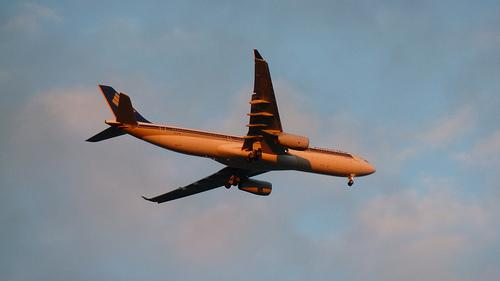What type of vehicle is in the image, and what is its color? The vehicle in the image is an airplane, and its color is white. Is the plane flying to the left? The airplane is flying to the right. Are there three engines on the airplane? The airplane has two engines. Is the plane not in the sky? The airplane is in the sky. Does the sky have no clouds? The sky has clouds. Is the airplane's color red? The airplane is white. Are there four wheels underneath the front of the plane? There are two wheels underneath the front of the plane. 